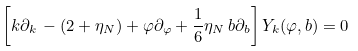Convert formula to latex. <formula><loc_0><loc_0><loc_500><loc_500>\left [ k \partial _ { k } \, - ( 2 + \eta _ { N } ) + \varphi \partial _ { \varphi } + \frac { 1 } { 6 } \eta _ { N } \, b \partial _ { b } \right ] Y _ { k } ( \varphi , b ) = 0</formula> 